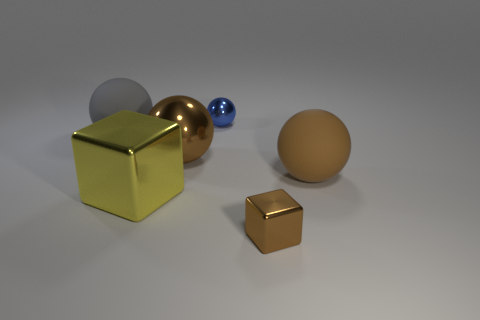Are there any large objects that have the same color as the small metal block?
Your response must be concise. Yes. The blue object that is made of the same material as the yellow thing is what size?
Your answer should be compact. Small. Are there more small objects that are in front of the large brown metal object than brown things behind the big gray rubber ball?
Offer a terse response. Yes. What number of other objects are the same material as the big yellow thing?
Provide a short and direct response. 3. Do the sphere that is on the right side of the tiny brown block and the gray object have the same material?
Make the answer very short. Yes. There is a large brown rubber thing; what shape is it?
Your response must be concise. Sphere. Are there more shiny cubes that are to the right of the large yellow cube than large green metal blocks?
Provide a succinct answer. Yes. Is there any other thing that is the same shape as the brown matte thing?
Offer a terse response. Yes. There is another rubber object that is the same shape as the brown rubber object; what color is it?
Keep it short and to the point. Gray. There is a small object in front of the small sphere; what is its shape?
Your answer should be compact. Cube. 